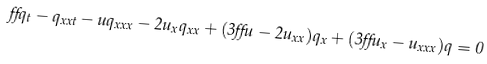Convert formula to latex. <formula><loc_0><loc_0><loc_500><loc_500>\alpha q _ { t } - q _ { x x t } - u q _ { x x x } - 2 u _ { x } q _ { x x } + ( 3 \alpha u - 2 u _ { x x } ) q _ { x } + ( 3 \alpha u _ { x } - u _ { x x x } ) q = 0</formula> 